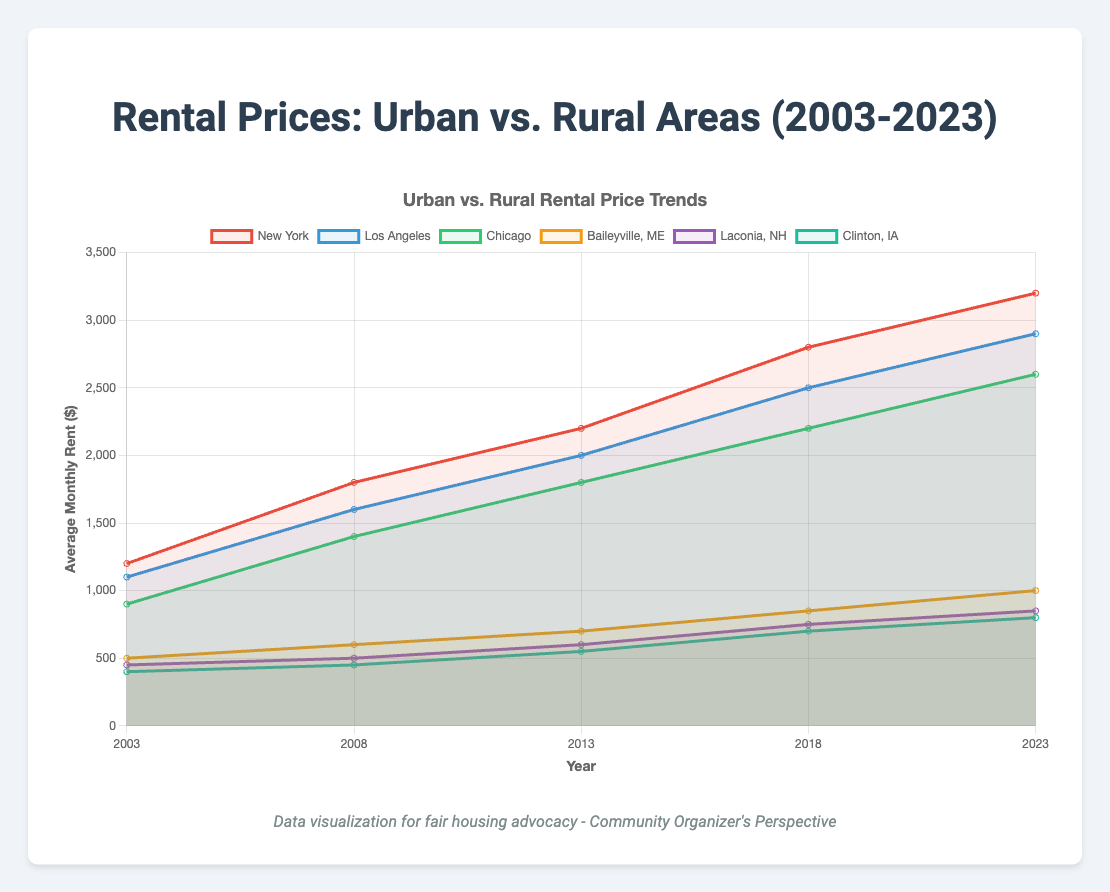What is the trend of rental prices in New York from 2003 to 2023? The rental prices in New York increase consistently over the years from 2003 to 2023. Specifically, they are $1200 in 2003, $1800 in 2008, $2200 in 2013, $2800 in 2018, and $3200 in 2023.
Answer: Increasing Which area had the greatest increase in rental prices from 2003 to 2023, New York or Baileyville, ME? New York's rental prices increased from $1200 in 2003 to $3200 in 2023, an increase of $2000. Baileyville, ME increased from $500 in 2003 to $1000 in 2023, an increase of $500. Thus, New York had a greater increase.
Answer: New York In 2023, which urban area has the highest average monthly rent, and which has the lowest? In 2023, New York has the highest rental price at $3200, and Chicago has the lowest at $2600 among the urban areas listed.
Answer: New York (highest), Chicago (lowest) Compare the rental price trends of Los Angeles and Laconia, NH from 2003 to 2023. Both Los Angeles and Laconia, NH show an increasing trend from 2003 to 2023. Los Angeles's prices went from $1100 to $2900, while Laconia, NH went from $450 to $850. Los Angeles starts higher and grows faster compared to Laconia.
Answer: Both increasing, LA grows faster What is the percentage increase in rental prices for Chicago from 2003 to 2023? Chicago's rental prices in 2003 were $900 and in 2023 are $2600. The increase is $1700. The percentage increase is calculated as ($1700/$900) * 100 ≈ 188.89%.
Answer: ≈ 188.89% Which year saw the biggest jump in rental price for Los Angeles? Between 2003 and 2008, the rental price increased from $1100 to $1600, an increase of $500. Between subsequent year ranges, the increases were $400 (2008-2013), $500 (2013-2018), and $400 (2018-2023). Thus, the biggest jump was in 2003-2008.
Answer: 2003-2008 Compare the rental price growth between urban and rural areas from 2003 to 2023. Urban areas like New York, Los Angeles, and Chicago saw increases of $2000, $1800, and $1700 respectively. Rural areas like Baileyville, Laconia, and Clinton saw increases of $500, $400, and $400 respectively. Thus, urban areas experienced much higher increases compared to rural areas.
Answer: Urban areas had higher growth What is the average rental price for all rural areas in 2023? The rental prices for rural areas in 2023 are Baileyville at $1000, Laconia at $850, and Clinton at $800. The average is calculated as ($1000 + $850 + $800) / 3 = $2650 / 3 ≈ $883.33.
Answer: ≈ $883.33 By how much did the rental prices in Clinton, IA increase from 2003 to 2023? The rental prices in Clinton, IA increased from $400 in 2003 to $800 in 2023. This is an increase of $800 - $400 = $400.
Answer: $400 In 2013, which region (urban or rural) had a larger disparity in rental prices among its listed areas? In 2013, urban areas had New York at $2200, Los Angeles at $2000, and Chicago at $1800, a disparity of $2200 - $1800 = $400. Rural areas had Baileyville at $700, Laconia at $600, and Clinton at $550, a disparity of $700 - $550 = $150. Thus, urban areas had a larger disparity.
Answer: Urban areas 